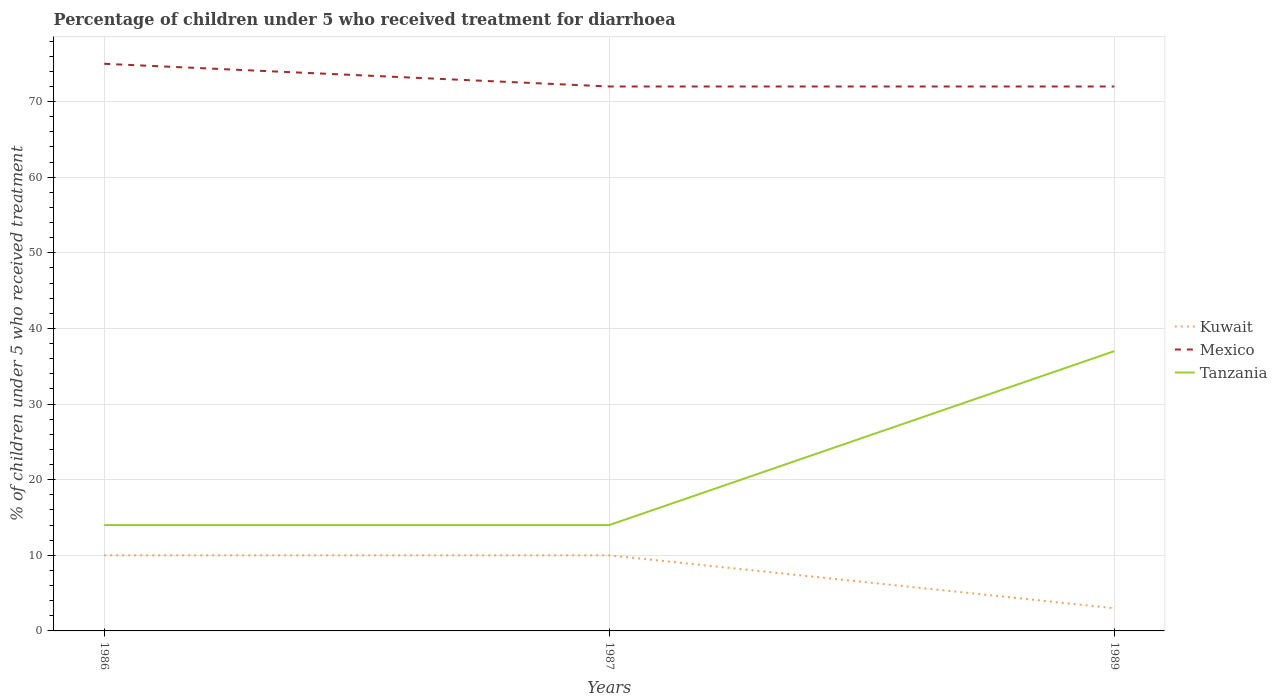How many different coloured lines are there?
Offer a terse response. 3. In which year was the percentage of children who received treatment for diarrhoea  in Kuwait maximum?
Make the answer very short. 1989. What is the total percentage of children who received treatment for diarrhoea  in Kuwait in the graph?
Ensure brevity in your answer.  7. What is the difference between the highest and the lowest percentage of children who received treatment for diarrhoea  in Tanzania?
Your answer should be very brief. 1. How many lines are there?
Your answer should be very brief. 3. How many years are there in the graph?
Your response must be concise. 3. Are the values on the major ticks of Y-axis written in scientific E-notation?
Provide a succinct answer. No. Does the graph contain grids?
Keep it short and to the point. Yes. Where does the legend appear in the graph?
Offer a terse response. Center right. How many legend labels are there?
Your answer should be compact. 3. How are the legend labels stacked?
Offer a very short reply. Vertical. What is the title of the graph?
Your answer should be compact. Percentage of children under 5 who received treatment for diarrhoea. What is the label or title of the Y-axis?
Your answer should be very brief. % of children under 5 who received treatment. What is the % of children under 5 who received treatment in Kuwait in 1986?
Ensure brevity in your answer.  10. What is the % of children under 5 who received treatment in Mexico in 1986?
Make the answer very short. 75. What is the % of children under 5 who received treatment in Mexico in 1987?
Offer a terse response. 72. Across all years, what is the maximum % of children under 5 who received treatment of Kuwait?
Provide a succinct answer. 10. Across all years, what is the maximum % of children under 5 who received treatment of Tanzania?
Your answer should be compact. 37. Across all years, what is the minimum % of children under 5 who received treatment of Mexico?
Offer a terse response. 72. Across all years, what is the minimum % of children under 5 who received treatment of Tanzania?
Make the answer very short. 14. What is the total % of children under 5 who received treatment in Mexico in the graph?
Offer a terse response. 219. What is the total % of children under 5 who received treatment of Tanzania in the graph?
Give a very brief answer. 65. What is the difference between the % of children under 5 who received treatment of Mexico in 1986 and that in 1987?
Keep it short and to the point. 3. What is the difference between the % of children under 5 who received treatment of Tanzania in 1986 and that in 1987?
Provide a succinct answer. 0. What is the difference between the % of children under 5 who received treatment of Mexico in 1986 and that in 1989?
Offer a terse response. 3. What is the difference between the % of children under 5 who received treatment of Kuwait in 1987 and that in 1989?
Your response must be concise. 7. What is the difference between the % of children under 5 who received treatment in Mexico in 1987 and that in 1989?
Make the answer very short. 0. What is the difference between the % of children under 5 who received treatment of Tanzania in 1987 and that in 1989?
Offer a very short reply. -23. What is the difference between the % of children under 5 who received treatment of Kuwait in 1986 and the % of children under 5 who received treatment of Mexico in 1987?
Provide a succinct answer. -62. What is the difference between the % of children under 5 who received treatment of Kuwait in 1986 and the % of children under 5 who received treatment of Tanzania in 1987?
Give a very brief answer. -4. What is the difference between the % of children under 5 who received treatment of Kuwait in 1986 and the % of children under 5 who received treatment of Mexico in 1989?
Offer a terse response. -62. What is the difference between the % of children under 5 who received treatment in Mexico in 1986 and the % of children under 5 who received treatment in Tanzania in 1989?
Ensure brevity in your answer.  38. What is the difference between the % of children under 5 who received treatment in Kuwait in 1987 and the % of children under 5 who received treatment in Mexico in 1989?
Make the answer very short. -62. What is the difference between the % of children under 5 who received treatment of Mexico in 1987 and the % of children under 5 who received treatment of Tanzania in 1989?
Offer a very short reply. 35. What is the average % of children under 5 who received treatment of Kuwait per year?
Keep it short and to the point. 7.67. What is the average % of children under 5 who received treatment of Mexico per year?
Offer a terse response. 73. What is the average % of children under 5 who received treatment of Tanzania per year?
Make the answer very short. 21.67. In the year 1986, what is the difference between the % of children under 5 who received treatment of Kuwait and % of children under 5 who received treatment of Mexico?
Offer a very short reply. -65. In the year 1986, what is the difference between the % of children under 5 who received treatment of Kuwait and % of children under 5 who received treatment of Tanzania?
Your answer should be very brief. -4. In the year 1987, what is the difference between the % of children under 5 who received treatment in Kuwait and % of children under 5 who received treatment in Mexico?
Your answer should be compact. -62. In the year 1987, what is the difference between the % of children under 5 who received treatment of Kuwait and % of children under 5 who received treatment of Tanzania?
Provide a short and direct response. -4. In the year 1989, what is the difference between the % of children under 5 who received treatment in Kuwait and % of children under 5 who received treatment in Mexico?
Make the answer very short. -69. In the year 1989, what is the difference between the % of children under 5 who received treatment of Kuwait and % of children under 5 who received treatment of Tanzania?
Ensure brevity in your answer.  -34. In the year 1989, what is the difference between the % of children under 5 who received treatment of Mexico and % of children under 5 who received treatment of Tanzania?
Your answer should be very brief. 35. What is the ratio of the % of children under 5 who received treatment in Mexico in 1986 to that in 1987?
Your answer should be compact. 1.04. What is the ratio of the % of children under 5 who received treatment of Mexico in 1986 to that in 1989?
Ensure brevity in your answer.  1.04. What is the ratio of the % of children under 5 who received treatment in Tanzania in 1986 to that in 1989?
Offer a very short reply. 0.38. What is the ratio of the % of children under 5 who received treatment in Tanzania in 1987 to that in 1989?
Ensure brevity in your answer.  0.38. What is the difference between the highest and the second highest % of children under 5 who received treatment of Kuwait?
Your answer should be very brief. 0. What is the difference between the highest and the second highest % of children under 5 who received treatment in Tanzania?
Your response must be concise. 23. What is the difference between the highest and the lowest % of children under 5 who received treatment of Kuwait?
Keep it short and to the point. 7. What is the difference between the highest and the lowest % of children under 5 who received treatment of Tanzania?
Your answer should be compact. 23. 